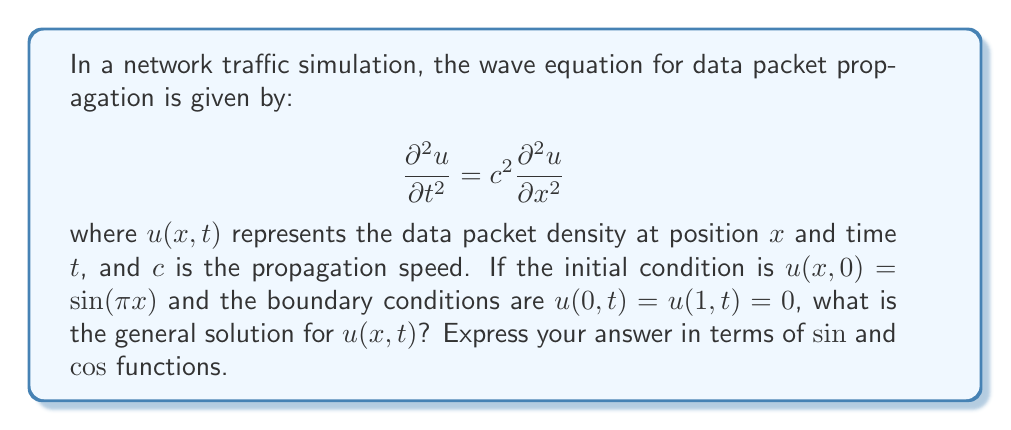Give your solution to this math problem. To solve this wave equation with the given initial and boundary conditions, we'll follow these steps:

1) The general solution for the wave equation with these boundary conditions has the form:

   $$u(x,t) = \sum_{n=1}^{\infty} (A_n \cos(n\pi ct) + B_n \sin(n\pi ct)) \sin(n\pi x)$$

2) Given the initial condition $u(x,0) = \sin(\pi x)$, we can determine that only the first term in the series (n=1) is non-zero, and $A_1 = 1$, while all other $A_n$ and $B_n$ are zero.

3) To find $B_1$, we need to use the initial velocity condition. However, it's not provided in the problem. In the absence of this information, we'll keep $B_1$ as an unknown constant.

4) Therefore, our solution simplifies to:

   $$u(x,t) = \cos(\pi ct) \sin(\pi x) + B_1 \sin(\pi ct) \sin(\pi x)$$

5) This can be rewritten as:

   $$u(x,t) = (\cos(\pi ct) + B_1 \sin(\pi ct)) \sin(\pi x)$$

This form represents a standing wave, which is consistent with the fixed boundary conditions.
Answer: $$u(x,t) = (\cos(\pi ct) + B_1 \sin(\pi ct)) \sin(\pi x)$$ 